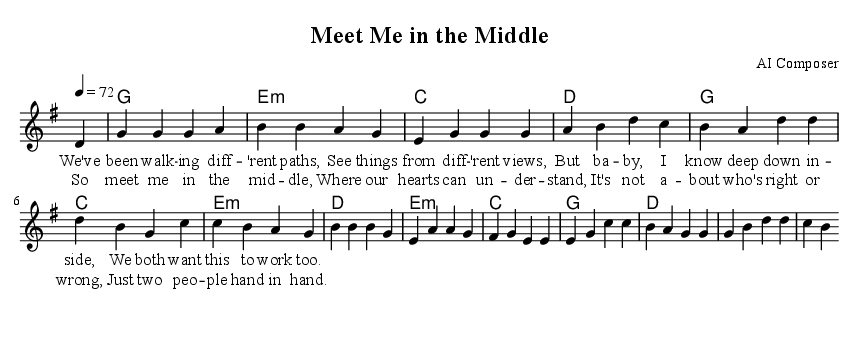What is the key signature of this music? The key signature is G major, which has one sharp (F#). This can be determined by looking for the segment indicating the key signature in the score.
Answer: G major What is the time signature of this piece? The time signature is 4/4, which is indicated at the beginning of the score. This means there are four beats in each measure, and the quarter note receives one beat.
Answer: 4/4 What is the tempo marking for the piece? The tempo marking is 72 beats per minute, shown as "4 = 72" in the global settings. This indicates the speed at which the piece should be played.
Answer: 72 What chord follows the 'g' chord in the harmonies? The chord that follows the 'g' chord is 'e minor'. This can be seen in the chord sequence aligned with the melody in the scores.
Answer: e minor How many measures are in the chorus? The chorus consists of 4 measures. By counting the vertical lines indicating the end of measures in the chorus section, we can identify this.
Answer: 4 What is the central theme expressed in the lyrics? The central theme expressed in the lyrics is about compromise in relationships, emphasizing understanding and teamwork. This is deduced from the use of phrases that advocate meeting "in the middle."
Answer: Compromise What instrument is primarily featured in the melody? The melody is primarily featured in the voice. This is indicated by the notation for the lead voice in the score provided.
Answer: Voice 